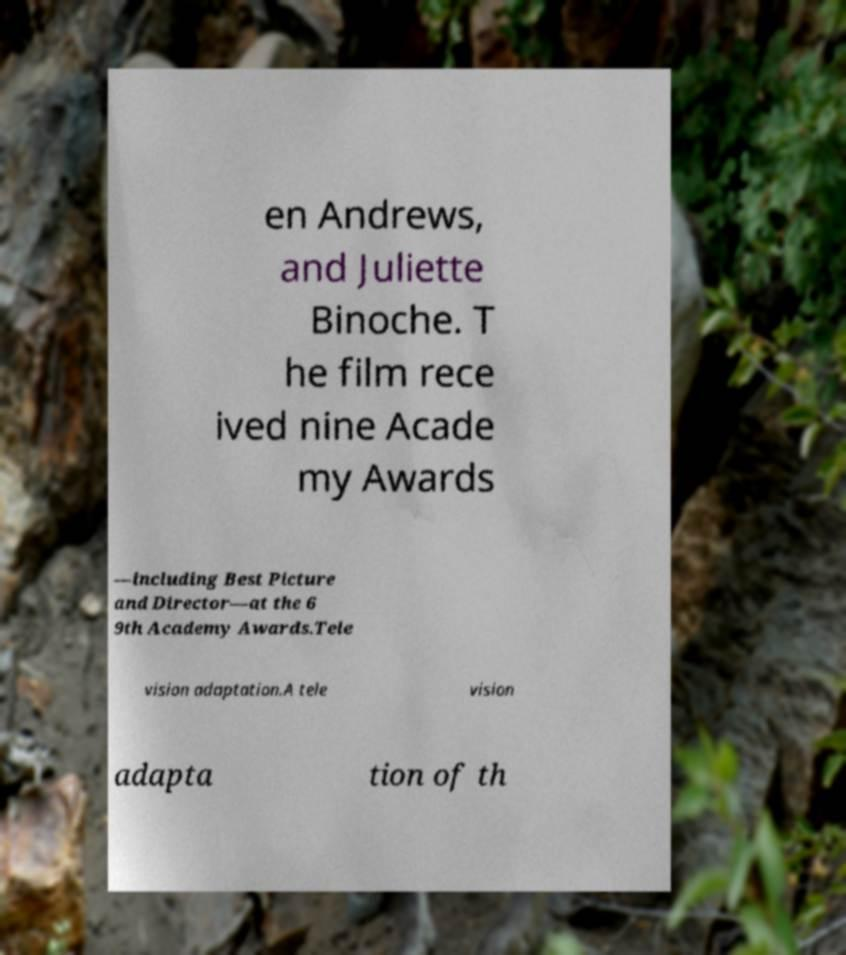There's text embedded in this image that I need extracted. Can you transcribe it verbatim? en Andrews, and Juliette Binoche. T he film rece ived nine Acade my Awards —including Best Picture and Director—at the 6 9th Academy Awards.Tele vision adaptation.A tele vision adapta tion of th 